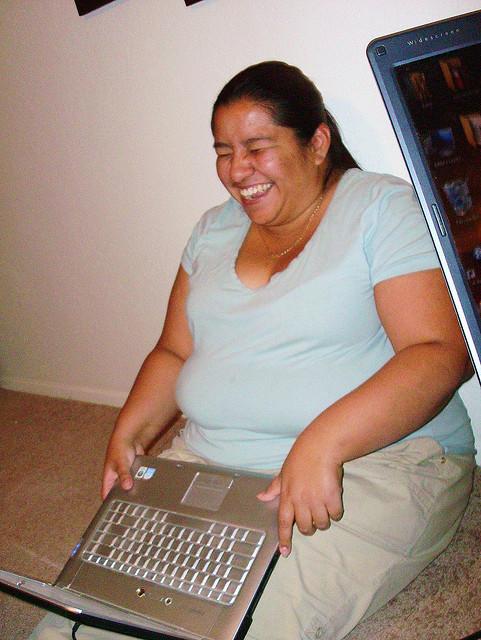Is this person mad?
Keep it brief. No. What brand of laptop is this?
Give a very brief answer. Dell. Where is she sitting?
Answer briefly. Floor. Is the person holding the same type of item that is visible on the right side of the screen?
Answer briefly. Yes. 